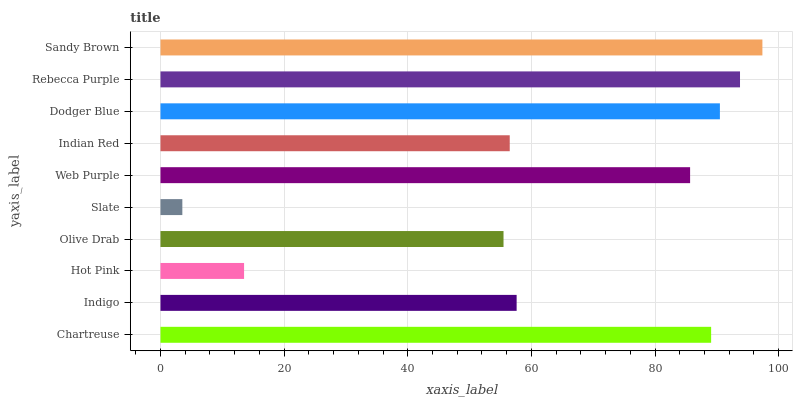Is Slate the minimum?
Answer yes or no. Yes. Is Sandy Brown the maximum?
Answer yes or no. Yes. Is Indigo the minimum?
Answer yes or no. No. Is Indigo the maximum?
Answer yes or no. No. Is Chartreuse greater than Indigo?
Answer yes or no. Yes. Is Indigo less than Chartreuse?
Answer yes or no. Yes. Is Indigo greater than Chartreuse?
Answer yes or no. No. Is Chartreuse less than Indigo?
Answer yes or no. No. Is Web Purple the high median?
Answer yes or no. Yes. Is Indigo the low median?
Answer yes or no. Yes. Is Sandy Brown the high median?
Answer yes or no. No. Is Slate the low median?
Answer yes or no. No. 